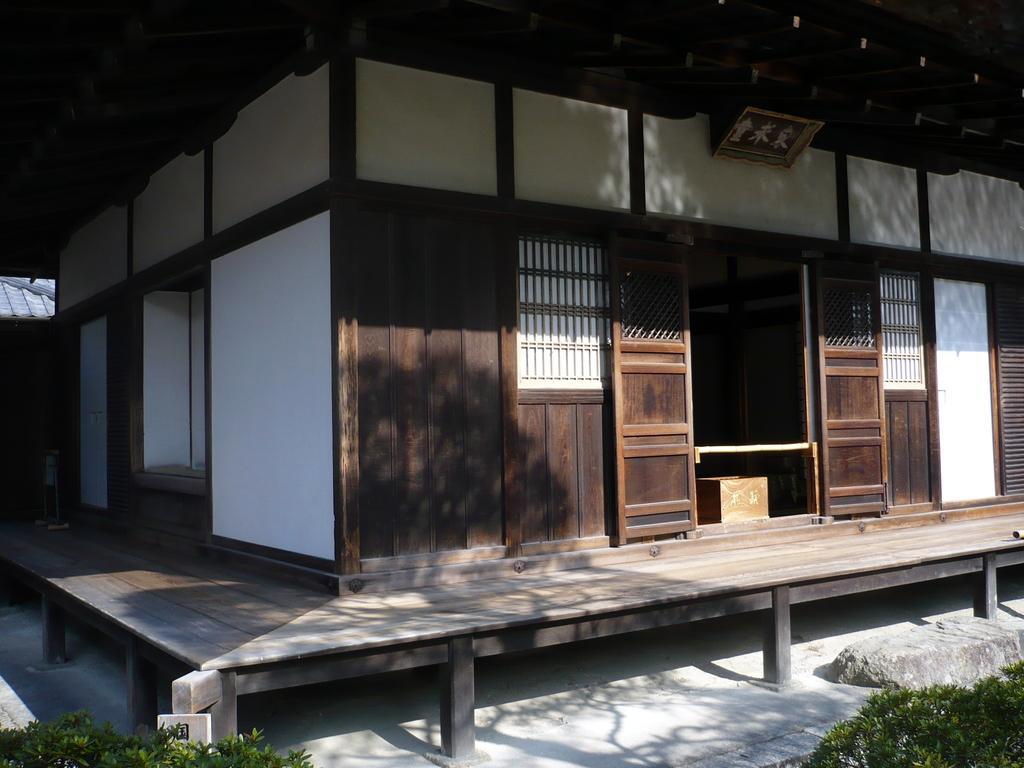Please provide a concise description of this image. In the center of the image, we can see a wooden house and at the top, there is roof and there is a frame. At the bottom, there are plants and we can see a stone and floor. 